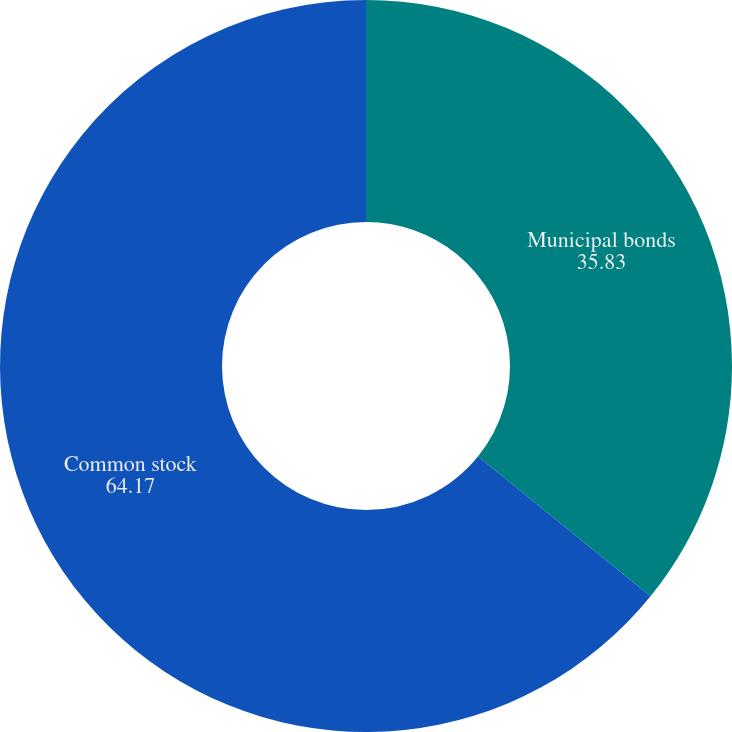Convert chart. <chart><loc_0><loc_0><loc_500><loc_500><pie_chart><fcel>Municipal bonds<fcel>Common stock<nl><fcel>35.83%<fcel>64.17%<nl></chart> 